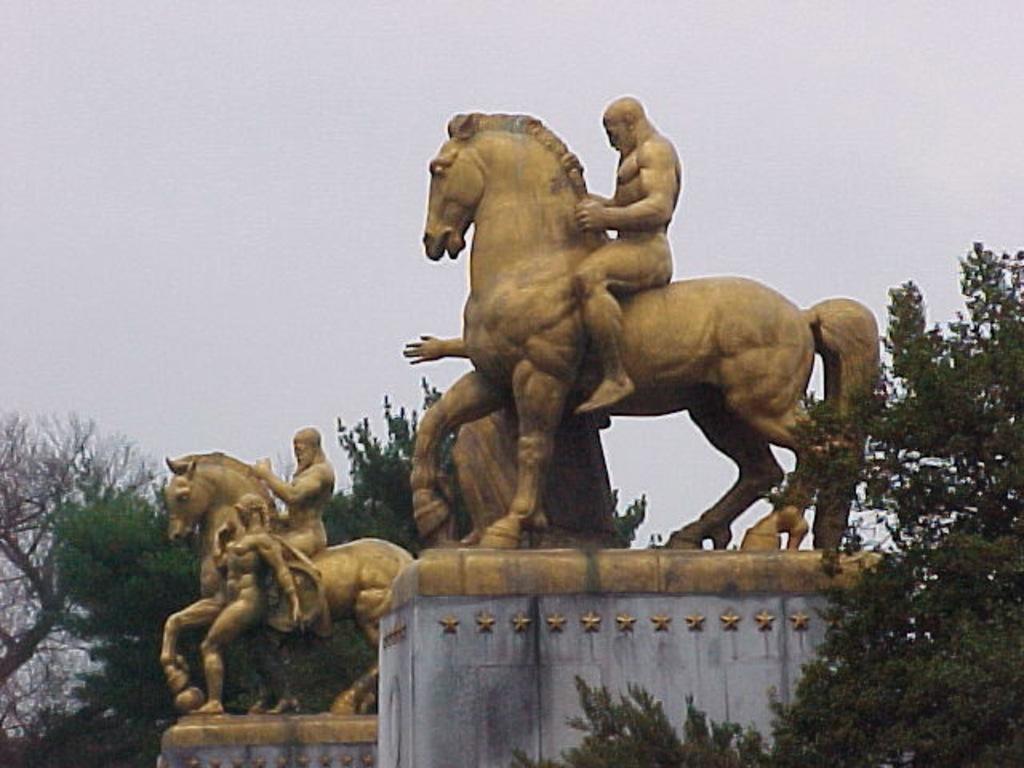How would you summarize this image in a sentence or two? In this picture there are two statues of horse and man sitting on it and another statue it has a person riding a horse and a person standing beside them, in the background there are trees and the sky is clear 